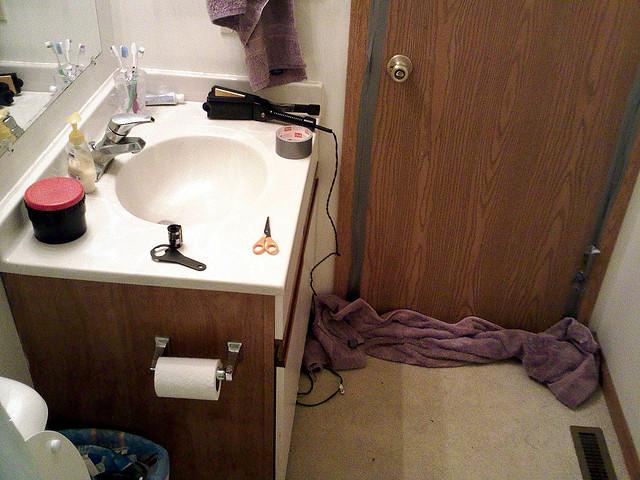Why is the door sealed with duct tape and a towel?
Quick response, please. To prevent sounds from leaving. Is the toilet lid up?
Be succinct. Yes. Where is the toilet paper?
Concise answer only. On roll. 